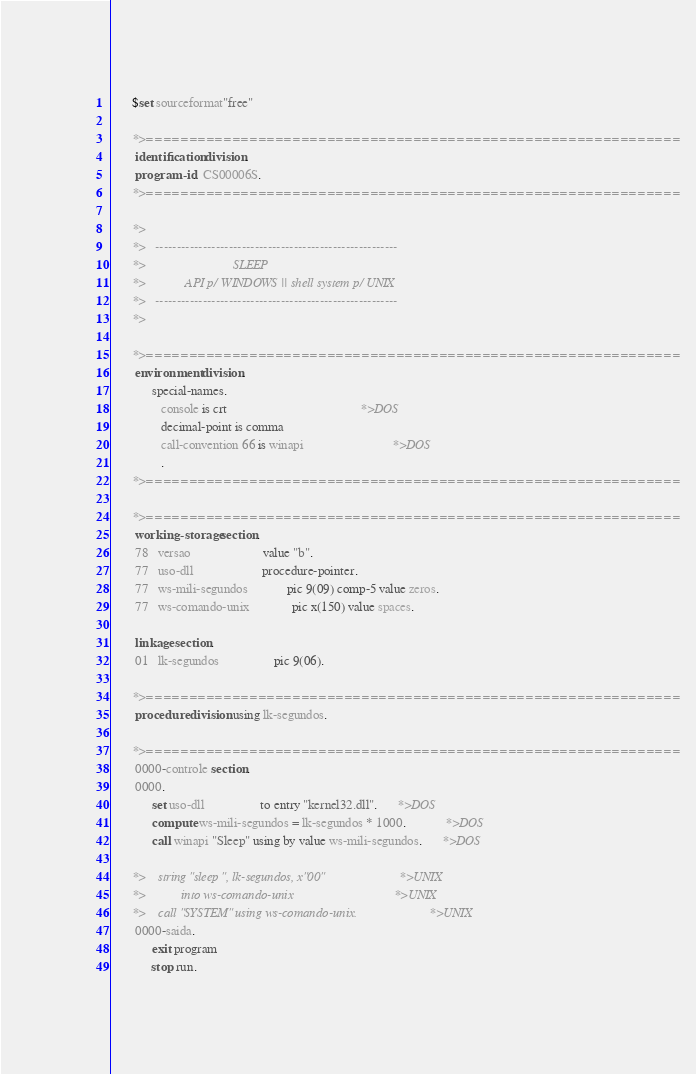<code> <loc_0><loc_0><loc_500><loc_500><_COBOL_>      $set sourceformat"free"

      *>==============================================================
       identification division.
       program-id.  CS00006S.
      *>==============================================================

      *>
      *>   --------------------------------------------------------
      *>                           SLEEP
      *>            API p/ WINDOWS || shell system p/ UNIX
      *>   --------------------------------------------------------
      *>

      *>==============================================================
       environment division.
            special-names.
               console is crt                                         *>DOS
               decimal-point is comma
               call-convention 66 is winapi                           *>DOS
               .
      *>==============================================================

      *>==============================================================
       working-storage section.
       78   versao                      value "b".
       77   uso-dll                     procedure-pointer.
       77   ws-mili-segundos            pic 9(09) comp-5 value zeros.
       77   ws-comando-unix             pic x(150) value spaces.

       linkage section.
       01   lk-segundos                 pic 9(06).

      *>==============================================================
       procedure division using lk-segundos.

      *>==============================================================
       0000-controle section.
       0000.
            set uso-dll                 to entry "kernel32.dll".      *>DOS
            compute ws-mili-segundos = lk-segundos * 1000.            *>DOS
            call winapi "Sleep" using by value ws-mili-segundos.      *>DOS

      *>    string "sleep ", lk-segundos, x"00"                       *>UNIX
      *>           into ws-comando-unix                               *>UNIX
      *>    call "SYSTEM" using ws-comando-unix.                      *>UNIX
       0000-saida.
            exit program
            stop run.</code> 